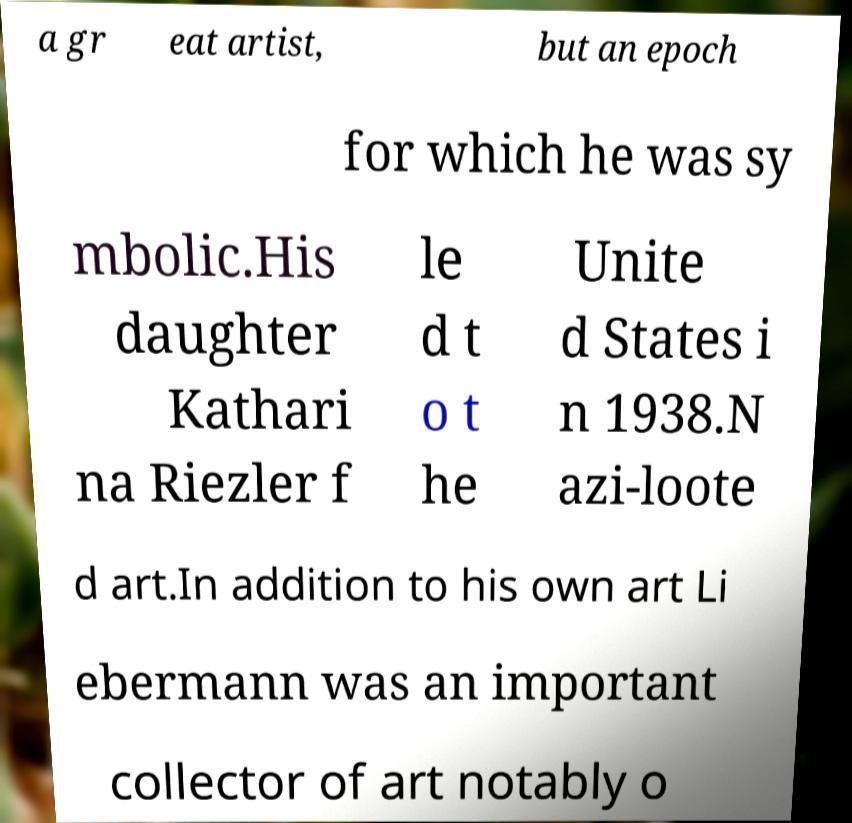Can you read and provide the text displayed in the image?This photo seems to have some interesting text. Can you extract and type it out for me? a gr eat artist, but an epoch for which he was sy mbolic.His daughter Kathari na Riezler f le d t o t he Unite d States i n 1938.N azi-loote d art.In addition to his own art Li ebermann was an important collector of art notably o 